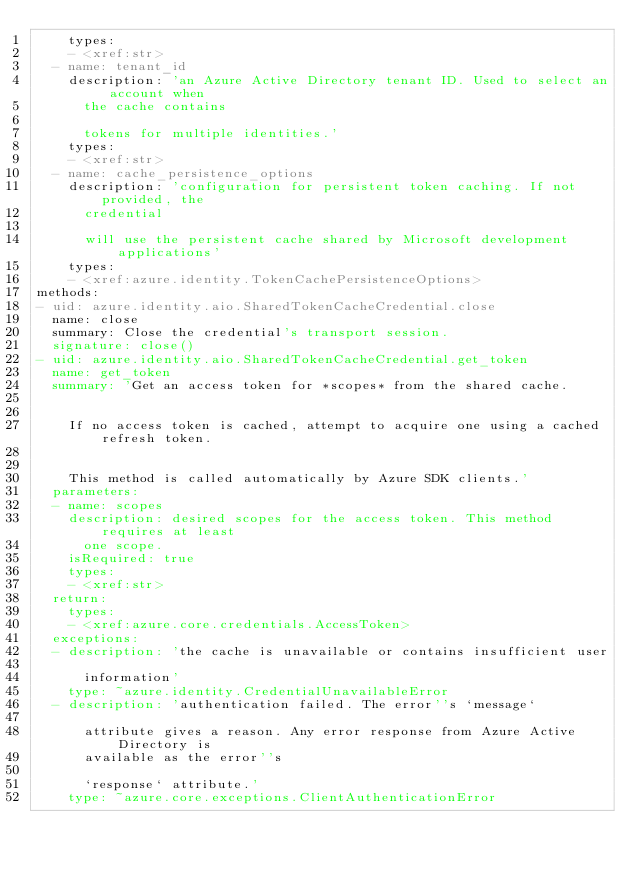Convert code to text. <code><loc_0><loc_0><loc_500><loc_500><_YAML_>    types:
    - <xref:str>
  - name: tenant_id
    description: 'an Azure Active Directory tenant ID. Used to select an account when
      the cache contains

      tokens for multiple identities.'
    types:
    - <xref:str>
  - name: cache_persistence_options
    description: 'configuration for persistent token caching. If not provided, the
      credential

      will use the persistent cache shared by Microsoft development applications'
    types:
    - <xref:azure.identity.TokenCachePersistenceOptions>
methods:
- uid: azure.identity.aio.SharedTokenCacheCredential.close
  name: close
  summary: Close the credential's transport session.
  signature: close()
- uid: azure.identity.aio.SharedTokenCacheCredential.get_token
  name: get_token
  summary: 'Get an access token for *scopes* from the shared cache.


    If no access token is cached, attempt to acquire one using a cached refresh token.


    This method is called automatically by Azure SDK clients.'
  parameters:
  - name: scopes
    description: desired scopes for the access token. This method requires at least
      one scope.
    isRequired: true
    types:
    - <xref:str>
  return:
    types:
    - <xref:azure.core.credentials.AccessToken>
  exceptions:
  - description: 'the cache is unavailable or contains insufficient user

      information'
    type: ~azure.identity.CredentialUnavailableError
  - description: 'authentication failed. The error''s `message`

      attribute gives a reason. Any error response from Azure Active Directory is
      available as the error''s

      `response` attribute.'
    type: ~azure.core.exceptions.ClientAuthenticationError
</code> 